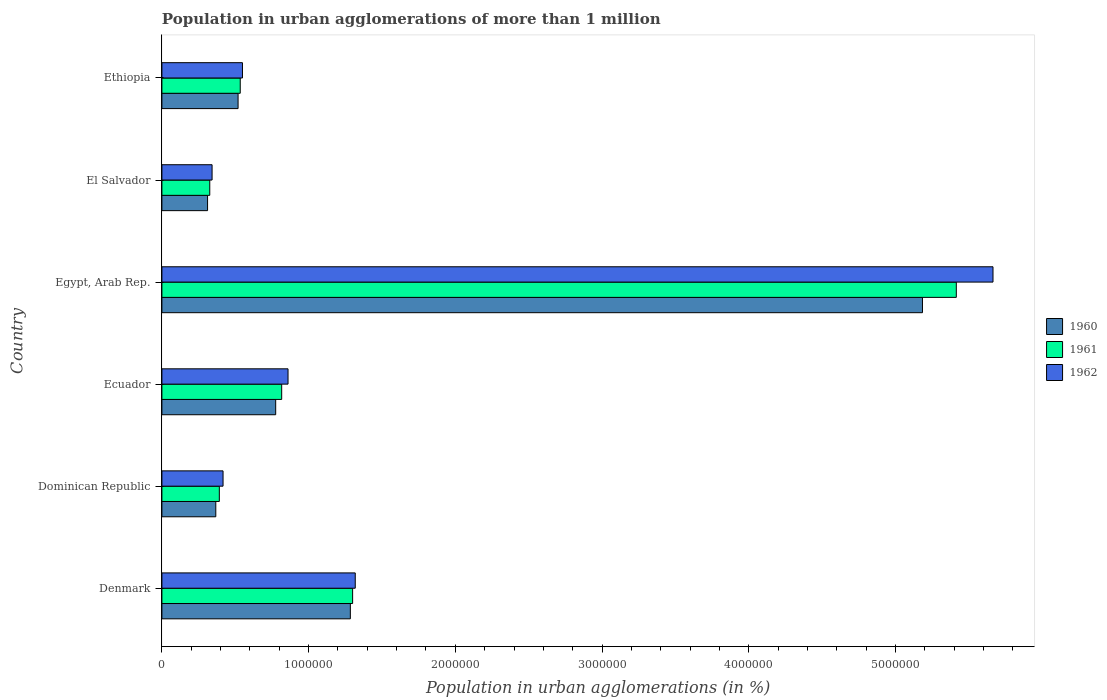How many different coloured bars are there?
Provide a short and direct response. 3. How many groups of bars are there?
Ensure brevity in your answer.  6. Are the number of bars per tick equal to the number of legend labels?
Offer a very short reply. Yes. Are the number of bars on each tick of the Y-axis equal?
Your answer should be compact. Yes. How many bars are there on the 4th tick from the bottom?
Provide a short and direct response. 3. What is the label of the 5th group of bars from the top?
Offer a terse response. Dominican Republic. In how many cases, is the number of bars for a given country not equal to the number of legend labels?
Your answer should be compact. 0. What is the population in urban agglomerations in 1960 in Denmark?
Make the answer very short. 1.28e+06. Across all countries, what is the maximum population in urban agglomerations in 1962?
Your response must be concise. 5.66e+06. Across all countries, what is the minimum population in urban agglomerations in 1962?
Keep it short and to the point. 3.42e+05. In which country was the population in urban agglomerations in 1962 maximum?
Ensure brevity in your answer.  Egypt, Arab Rep. In which country was the population in urban agglomerations in 1962 minimum?
Ensure brevity in your answer.  El Salvador. What is the total population in urban agglomerations in 1962 in the graph?
Provide a short and direct response. 9.15e+06. What is the difference between the population in urban agglomerations in 1962 in Egypt, Arab Rep. and that in Ethiopia?
Your answer should be compact. 5.12e+06. What is the difference between the population in urban agglomerations in 1962 in El Salvador and the population in urban agglomerations in 1961 in Ethiopia?
Provide a short and direct response. -1.92e+05. What is the average population in urban agglomerations in 1960 per country?
Ensure brevity in your answer.  1.41e+06. What is the difference between the population in urban agglomerations in 1961 and population in urban agglomerations in 1962 in Ethiopia?
Make the answer very short. -1.52e+04. In how many countries, is the population in urban agglomerations in 1960 greater than 1000000 %?
Provide a short and direct response. 2. What is the ratio of the population in urban agglomerations in 1962 in Ecuador to that in Egypt, Arab Rep.?
Provide a succinct answer. 0.15. What is the difference between the highest and the second highest population in urban agglomerations in 1962?
Ensure brevity in your answer.  4.35e+06. What is the difference between the highest and the lowest population in urban agglomerations in 1960?
Provide a short and direct response. 4.87e+06. In how many countries, is the population in urban agglomerations in 1960 greater than the average population in urban agglomerations in 1960 taken over all countries?
Provide a succinct answer. 1. Is the sum of the population in urban agglomerations in 1960 in Egypt, Arab Rep. and El Salvador greater than the maximum population in urban agglomerations in 1961 across all countries?
Ensure brevity in your answer.  Yes. What does the 2nd bar from the top in Dominican Republic represents?
Ensure brevity in your answer.  1961. How many countries are there in the graph?
Your answer should be very brief. 6. What is the difference between two consecutive major ticks on the X-axis?
Your answer should be compact. 1.00e+06. Are the values on the major ticks of X-axis written in scientific E-notation?
Provide a short and direct response. No. Does the graph contain any zero values?
Your answer should be very brief. No. Does the graph contain grids?
Offer a terse response. No. Where does the legend appear in the graph?
Keep it short and to the point. Center right. How are the legend labels stacked?
Offer a terse response. Vertical. What is the title of the graph?
Offer a very short reply. Population in urban agglomerations of more than 1 million. What is the label or title of the X-axis?
Provide a short and direct response. Population in urban agglomerations (in %). What is the label or title of the Y-axis?
Your response must be concise. Country. What is the Population in urban agglomerations (in %) in 1960 in Denmark?
Offer a terse response. 1.28e+06. What is the Population in urban agglomerations (in %) in 1961 in Denmark?
Keep it short and to the point. 1.30e+06. What is the Population in urban agglomerations (in %) in 1962 in Denmark?
Your answer should be very brief. 1.32e+06. What is the Population in urban agglomerations (in %) of 1960 in Dominican Republic?
Give a very brief answer. 3.67e+05. What is the Population in urban agglomerations (in %) of 1961 in Dominican Republic?
Keep it short and to the point. 3.91e+05. What is the Population in urban agglomerations (in %) of 1962 in Dominican Republic?
Offer a very short reply. 4.17e+05. What is the Population in urban agglomerations (in %) of 1960 in Ecuador?
Provide a succinct answer. 7.76e+05. What is the Population in urban agglomerations (in %) in 1961 in Ecuador?
Your answer should be compact. 8.16e+05. What is the Population in urban agglomerations (in %) in 1962 in Ecuador?
Give a very brief answer. 8.60e+05. What is the Population in urban agglomerations (in %) in 1960 in Egypt, Arab Rep.?
Give a very brief answer. 5.18e+06. What is the Population in urban agglomerations (in %) of 1961 in Egypt, Arab Rep.?
Your response must be concise. 5.41e+06. What is the Population in urban agglomerations (in %) in 1962 in Egypt, Arab Rep.?
Give a very brief answer. 5.66e+06. What is the Population in urban agglomerations (in %) in 1960 in El Salvador?
Your answer should be very brief. 3.11e+05. What is the Population in urban agglomerations (in %) of 1961 in El Salvador?
Your answer should be very brief. 3.26e+05. What is the Population in urban agglomerations (in %) of 1962 in El Salvador?
Make the answer very short. 3.42e+05. What is the Population in urban agglomerations (in %) in 1960 in Ethiopia?
Your answer should be very brief. 5.19e+05. What is the Population in urban agglomerations (in %) of 1961 in Ethiopia?
Give a very brief answer. 5.34e+05. What is the Population in urban agglomerations (in %) of 1962 in Ethiopia?
Your answer should be compact. 5.49e+05. Across all countries, what is the maximum Population in urban agglomerations (in %) in 1960?
Give a very brief answer. 5.18e+06. Across all countries, what is the maximum Population in urban agglomerations (in %) in 1961?
Give a very brief answer. 5.41e+06. Across all countries, what is the maximum Population in urban agglomerations (in %) in 1962?
Provide a short and direct response. 5.66e+06. Across all countries, what is the minimum Population in urban agglomerations (in %) of 1960?
Make the answer very short. 3.11e+05. Across all countries, what is the minimum Population in urban agglomerations (in %) of 1961?
Give a very brief answer. 3.26e+05. Across all countries, what is the minimum Population in urban agglomerations (in %) in 1962?
Offer a terse response. 3.42e+05. What is the total Population in urban agglomerations (in %) of 1960 in the graph?
Your answer should be very brief. 8.44e+06. What is the total Population in urban agglomerations (in %) in 1961 in the graph?
Give a very brief answer. 8.78e+06. What is the total Population in urban agglomerations (in %) of 1962 in the graph?
Make the answer very short. 9.15e+06. What is the difference between the Population in urban agglomerations (in %) of 1960 in Denmark and that in Dominican Republic?
Offer a terse response. 9.17e+05. What is the difference between the Population in urban agglomerations (in %) of 1961 in Denmark and that in Dominican Republic?
Your answer should be compact. 9.09e+05. What is the difference between the Population in urban agglomerations (in %) in 1962 in Denmark and that in Dominican Republic?
Provide a succinct answer. 9.01e+05. What is the difference between the Population in urban agglomerations (in %) in 1960 in Denmark and that in Ecuador?
Keep it short and to the point. 5.09e+05. What is the difference between the Population in urban agglomerations (in %) of 1961 in Denmark and that in Ecuador?
Your answer should be very brief. 4.83e+05. What is the difference between the Population in urban agglomerations (in %) of 1962 in Denmark and that in Ecuador?
Your response must be concise. 4.58e+05. What is the difference between the Population in urban agglomerations (in %) of 1960 in Denmark and that in Egypt, Arab Rep.?
Provide a succinct answer. -3.90e+06. What is the difference between the Population in urban agglomerations (in %) of 1961 in Denmark and that in Egypt, Arab Rep.?
Your response must be concise. -4.11e+06. What is the difference between the Population in urban agglomerations (in %) of 1962 in Denmark and that in Egypt, Arab Rep.?
Make the answer very short. -4.35e+06. What is the difference between the Population in urban agglomerations (in %) in 1960 in Denmark and that in El Salvador?
Offer a very short reply. 9.73e+05. What is the difference between the Population in urban agglomerations (in %) of 1961 in Denmark and that in El Salvador?
Provide a short and direct response. 9.74e+05. What is the difference between the Population in urban agglomerations (in %) in 1962 in Denmark and that in El Salvador?
Offer a very short reply. 9.76e+05. What is the difference between the Population in urban agglomerations (in %) in 1960 in Denmark and that in Ethiopia?
Make the answer very short. 7.65e+05. What is the difference between the Population in urban agglomerations (in %) in 1961 in Denmark and that in Ethiopia?
Offer a very short reply. 7.66e+05. What is the difference between the Population in urban agglomerations (in %) of 1962 in Denmark and that in Ethiopia?
Provide a short and direct response. 7.69e+05. What is the difference between the Population in urban agglomerations (in %) of 1960 in Dominican Republic and that in Ecuador?
Provide a short and direct response. -4.08e+05. What is the difference between the Population in urban agglomerations (in %) in 1961 in Dominican Republic and that in Ecuador?
Provide a succinct answer. -4.25e+05. What is the difference between the Population in urban agglomerations (in %) in 1962 in Dominican Republic and that in Ecuador?
Provide a short and direct response. -4.43e+05. What is the difference between the Population in urban agglomerations (in %) in 1960 in Dominican Republic and that in Egypt, Arab Rep.?
Give a very brief answer. -4.82e+06. What is the difference between the Population in urban agglomerations (in %) in 1961 in Dominican Republic and that in Egypt, Arab Rep.?
Provide a succinct answer. -5.02e+06. What is the difference between the Population in urban agglomerations (in %) in 1962 in Dominican Republic and that in Egypt, Arab Rep.?
Offer a terse response. -5.25e+06. What is the difference between the Population in urban agglomerations (in %) of 1960 in Dominican Republic and that in El Salvador?
Keep it short and to the point. 5.61e+04. What is the difference between the Population in urban agglomerations (in %) in 1961 in Dominican Republic and that in El Salvador?
Your response must be concise. 6.52e+04. What is the difference between the Population in urban agglomerations (in %) in 1962 in Dominican Republic and that in El Salvador?
Ensure brevity in your answer.  7.48e+04. What is the difference between the Population in urban agglomerations (in %) in 1960 in Dominican Republic and that in Ethiopia?
Keep it short and to the point. -1.52e+05. What is the difference between the Population in urban agglomerations (in %) in 1961 in Dominican Republic and that in Ethiopia?
Your response must be concise. -1.43e+05. What is the difference between the Population in urban agglomerations (in %) of 1962 in Dominican Republic and that in Ethiopia?
Offer a terse response. -1.32e+05. What is the difference between the Population in urban agglomerations (in %) of 1960 in Ecuador and that in Egypt, Arab Rep.?
Your answer should be very brief. -4.41e+06. What is the difference between the Population in urban agglomerations (in %) in 1961 in Ecuador and that in Egypt, Arab Rep.?
Provide a short and direct response. -4.60e+06. What is the difference between the Population in urban agglomerations (in %) of 1962 in Ecuador and that in Egypt, Arab Rep.?
Offer a terse response. -4.81e+06. What is the difference between the Population in urban agglomerations (in %) of 1960 in Ecuador and that in El Salvador?
Make the answer very short. 4.64e+05. What is the difference between the Population in urban agglomerations (in %) of 1961 in Ecuador and that in El Salvador?
Provide a short and direct response. 4.90e+05. What is the difference between the Population in urban agglomerations (in %) of 1962 in Ecuador and that in El Salvador?
Provide a succinct answer. 5.18e+05. What is the difference between the Population in urban agglomerations (in %) of 1960 in Ecuador and that in Ethiopia?
Your answer should be very brief. 2.56e+05. What is the difference between the Population in urban agglomerations (in %) of 1961 in Ecuador and that in Ethiopia?
Give a very brief answer. 2.83e+05. What is the difference between the Population in urban agglomerations (in %) in 1962 in Ecuador and that in Ethiopia?
Your answer should be compact. 3.11e+05. What is the difference between the Population in urban agglomerations (in %) of 1960 in Egypt, Arab Rep. and that in El Salvador?
Provide a short and direct response. 4.87e+06. What is the difference between the Population in urban agglomerations (in %) in 1961 in Egypt, Arab Rep. and that in El Salvador?
Keep it short and to the point. 5.09e+06. What is the difference between the Population in urban agglomerations (in %) in 1962 in Egypt, Arab Rep. and that in El Salvador?
Provide a short and direct response. 5.32e+06. What is the difference between the Population in urban agglomerations (in %) of 1960 in Egypt, Arab Rep. and that in Ethiopia?
Provide a succinct answer. 4.66e+06. What is the difference between the Population in urban agglomerations (in %) of 1961 in Egypt, Arab Rep. and that in Ethiopia?
Offer a terse response. 4.88e+06. What is the difference between the Population in urban agglomerations (in %) of 1962 in Egypt, Arab Rep. and that in Ethiopia?
Your answer should be very brief. 5.12e+06. What is the difference between the Population in urban agglomerations (in %) in 1960 in El Salvador and that in Ethiopia?
Your answer should be very brief. -2.08e+05. What is the difference between the Population in urban agglomerations (in %) of 1961 in El Salvador and that in Ethiopia?
Your answer should be very brief. -2.08e+05. What is the difference between the Population in urban agglomerations (in %) in 1962 in El Salvador and that in Ethiopia?
Ensure brevity in your answer.  -2.07e+05. What is the difference between the Population in urban agglomerations (in %) of 1960 in Denmark and the Population in urban agglomerations (in %) of 1961 in Dominican Republic?
Your response must be concise. 8.93e+05. What is the difference between the Population in urban agglomerations (in %) of 1960 in Denmark and the Population in urban agglomerations (in %) of 1962 in Dominican Republic?
Offer a terse response. 8.68e+05. What is the difference between the Population in urban agglomerations (in %) in 1961 in Denmark and the Population in urban agglomerations (in %) in 1962 in Dominican Republic?
Your response must be concise. 8.83e+05. What is the difference between the Population in urban agglomerations (in %) of 1960 in Denmark and the Population in urban agglomerations (in %) of 1961 in Ecuador?
Provide a short and direct response. 4.68e+05. What is the difference between the Population in urban agglomerations (in %) of 1960 in Denmark and the Population in urban agglomerations (in %) of 1962 in Ecuador?
Your response must be concise. 4.25e+05. What is the difference between the Population in urban agglomerations (in %) of 1961 in Denmark and the Population in urban agglomerations (in %) of 1962 in Ecuador?
Your response must be concise. 4.40e+05. What is the difference between the Population in urban agglomerations (in %) in 1960 in Denmark and the Population in urban agglomerations (in %) in 1961 in Egypt, Arab Rep.?
Provide a short and direct response. -4.13e+06. What is the difference between the Population in urban agglomerations (in %) of 1960 in Denmark and the Population in urban agglomerations (in %) of 1962 in Egypt, Arab Rep.?
Your answer should be compact. -4.38e+06. What is the difference between the Population in urban agglomerations (in %) in 1961 in Denmark and the Population in urban agglomerations (in %) in 1962 in Egypt, Arab Rep.?
Ensure brevity in your answer.  -4.36e+06. What is the difference between the Population in urban agglomerations (in %) in 1960 in Denmark and the Population in urban agglomerations (in %) in 1961 in El Salvador?
Provide a short and direct response. 9.58e+05. What is the difference between the Population in urban agglomerations (in %) of 1960 in Denmark and the Population in urban agglomerations (in %) of 1962 in El Salvador?
Your answer should be compact. 9.42e+05. What is the difference between the Population in urban agglomerations (in %) of 1961 in Denmark and the Population in urban agglomerations (in %) of 1962 in El Salvador?
Offer a terse response. 9.58e+05. What is the difference between the Population in urban agglomerations (in %) of 1960 in Denmark and the Population in urban agglomerations (in %) of 1961 in Ethiopia?
Offer a very short reply. 7.50e+05. What is the difference between the Population in urban agglomerations (in %) in 1960 in Denmark and the Population in urban agglomerations (in %) in 1962 in Ethiopia?
Offer a terse response. 7.35e+05. What is the difference between the Population in urban agglomerations (in %) of 1961 in Denmark and the Population in urban agglomerations (in %) of 1962 in Ethiopia?
Your answer should be very brief. 7.51e+05. What is the difference between the Population in urban agglomerations (in %) in 1960 in Dominican Republic and the Population in urban agglomerations (in %) in 1961 in Ecuador?
Your answer should be compact. -4.49e+05. What is the difference between the Population in urban agglomerations (in %) in 1960 in Dominican Republic and the Population in urban agglomerations (in %) in 1962 in Ecuador?
Provide a succinct answer. -4.92e+05. What is the difference between the Population in urban agglomerations (in %) of 1961 in Dominican Republic and the Population in urban agglomerations (in %) of 1962 in Ecuador?
Provide a short and direct response. -4.68e+05. What is the difference between the Population in urban agglomerations (in %) of 1960 in Dominican Republic and the Population in urban agglomerations (in %) of 1961 in Egypt, Arab Rep.?
Make the answer very short. -5.05e+06. What is the difference between the Population in urban agglomerations (in %) of 1960 in Dominican Republic and the Population in urban agglomerations (in %) of 1962 in Egypt, Arab Rep.?
Ensure brevity in your answer.  -5.30e+06. What is the difference between the Population in urban agglomerations (in %) of 1961 in Dominican Republic and the Population in urban agglomerations (in %) of 1962 in Egypt, Arab Rep.?
Provide a short and direct response. -5.27e+06. What is the difference between the Population in urban agglomerations (in %) in 1960 in Dominican Republic and the Population in urban agglomerations (in %) in 1961 in El Salvador?
Your answer should be very brief. 4.11e+04. What is the difference between the Population in urban agglomerations (in %) in 1960 in Dominican Republic and the Population in urban agglomerations (in %) in 1962 in El Salvador?
Your response must be concise. 2.53e+04. What is the difference between the Population in urban agglomerations (in %) of 1961 in Dominican Republic and the Population in urban agglomerations (in %) of 1962 in El Salvador?
Offer a very short reply. 4.94e+04. What is the difference between the Population in urban agglomerations (in %) in 1960 in Dominican Republic and the Population in urban agglomerations (in %) in 1961 in Ethiopia?
Offer a very short reply. -1.67e+05. What is the difference between the Population in urban agglomerations (in %) in 1960 in Dominican Republic and the Population in urban agglomerations (in %) in 1962 in Ethiopia?
Keep it short and to the point. -1.82e+05. What is the difference between the Population in urban agglomerations (in %) in 1961 in Dominican Republic and the Population in urban agglomerations (in %) in 1962 in Ethiopia?
Ensure brevity in your answer.  -1.58e+05. What is the difference between the Population in urban agglomerations (in %) of 1960 in Ecuador and the Population in urban agglomerations (in %) of 1961 in Egypt, Arab Rep.?
Provide a short and direct response. -4.64e+06. What is the difference between the Population in urban agglomerations (in %) in 1960 in Ecuador and the Population in urban agglomerations (in %) in 1962 in Egypt, Arab Rep.?
Your response must be concise. -4.89e+06. What is the difference between the Population in urban agglomerations (in %) in 1961 in Ecuador and the Population in urban agglomerations (in %) in 1962 in Egypt, Arab Rep.?
Keep it short and to the point. -4.85e+06. What is the difference between the Population in urban agglomerations (in %) of 1960 in Ecuador and the Population in urban agglomerations (in %) of 1961 in El Salvador?
Keep it short and to the point. 4.49e+05. What is the difference between the Population in urban agglomerations (in %) in 1960 in Ecuador and the Population in urban agglomerations (in %) in 1962 in El Salvador?
Make the answer very short. 4.34e+05. What is the difference between the Population in urban agglomerations (in %) of 1961 in Ecuador and the Population in urban agglomerations (in %) of 1962 in El Salvador?
Provide a short and direct response. 4.74e+05. What is the difference between the Population in urban agglomerations (in %) of 1960 in Ecuador and the Population in urban agglomerations (in %) of 1961 in Ethiopia?
Provide a succinct answer. 2.42e+05. What is the difference between the Population in urban agglomerations (in %) of 1960 in Ecuador and the Population in urban agglomerations (in %) of 1962 in Ethiopia?
Provide a succinct answer. 2.26e+05. What is the difference between the Population in urban agglomerations (in %) in 1961 in Ecuador and the Population in urban agglomerations (in %) in 1962 in Ethiopia?
Your answer should be very brief. 2.67e+05. What is the difference between the Population in urban agglomerations (in %) of 1960 in Egypt, Arab Rep. and the Population in urban agglomerations (in %) of 1961 in El Salvador?
Offer a very short reply. 4.86e+06. What is the difference between the Population in urban agglomerations (in %) in 1960 in Egypt, Arab Rep. and the Population in urban agglomerations (in %) in 1962 in El Salvador?
Ensure brevity in your answer.  4.84e+06. What is the difference between the Population in urban agglomerations (in %) in 1961 in Egypt, Arab Rep. and the Population in urban agglomerations (in %) in 1962 in El Salvador?
Make the answer very short. 5.07e+06. What is the difference between the Population in urban agglomerations (in %) in 1960 in Egypt, Arab Rep. and the Population in urban agglomerations (in %) in 1961 in Ethiopia?
Give a very brief answer. 4.65e+06. What is the difference between the Population in urban agglomerations (in %) in 1960 in Egypt, Arab Rep. and the Population in urban agglomerations (in %) in 1962 in Ethiopia?
Ensure brevity in your answer.  4.63e+06. What is the difference between the Population in urban agglomerations (in %) of 1961 in Egypt, Arab Rep. and the Population in urban agglomerations (in %) of 1962 in Ethiopia?
Offer a very short reply. 4.87e+06. What is the difference between the Population in urban agglomerations (in %) of 1960 in El Salvador and the Population in urban agglomerations (in %) of 1961 in Ethiopia?
Keep it short and to the point. -2.23e+05. What is the difference between the Population in urban agglomerations (in %) in 1960 in El Salvador and the Population in urban agglomerations (in %) in 1962 in Ethiopia?
Your answer should be compact. -2.38e+05. What is the difference between the Population in urban agglomerations (in %) of 1961 in El Salvador and the Population in urban agglomerations (in %) of 1962 in Ethiopia?
Your answer should be very brief. -2.23e+05. What is the average Population in urban agglomerations (in %) in 1960 per country?
Offer a terse response. 1.41e+06. What is the average Population in urban agglomerations (in %) of 1961 per country?
Make the answer very short. 1.46e+06. What is the average Population in urban agglomerations (in %) in 1962 per country?
Your answer should be very brief. 1.53e+06. What is the difference between the Population in urban agglomerations (in %) in 1960 and Population in urban agglomerations (in %) in 1961 in Denmark?
Provide a succinct answer. -1.55e+04. What is the difference between the Population in urban agglomerations (in %) in 1960 and Population in urban agglomerations (in %) in 1962 in Denmark?
Your answer should be compact. -3.34e+04. What is the difference between the Population in urban agglomerations (in %) of 1961 and Population in urban agglomerations (in %) of 1962 in Denmark?
Keep it short and to the point. -1.79e+04. What is the difference between the Population in urban agglomerations (in %) in 1960 and Population in urban agglomerations (in %) in 1961 in Dominican Republic?
Your answer should be compact. -2.41e+04. What is the difference between the Population in urban agglomerations (in %) in 1960 and Population in urban agglomerations (in %) in 1962 in Dominican Republic?
Offer a terse response. -4.95e+04. What is the difference between the Population in urban agglomerations (in %) in 1961 and Population in urban agglomerations (in %) in 1962 in Dominican Republic?
Your answer should be very brief. -2.54e+04. What is the difference between the Population in urban agglomerations (in %) in 1960 and Population in urban agglomerations (in %) in 1961 in Ecuador?
Provide a succinct answer. -4.09e+04. What is the difference between the Population in urban agglomerations (in %) in 1960 and Population in urban agglomerations (in %) in 1962 in Ecuador?
Provide a succinct answer. -8.41e+04. What is the difference between the Population in urban agglomerations (in %) in 1961 and Population in urban agglomerations (in %) in 1962 in Ecuador?
Ensure brevity in your answer.  -4.32e+04. What is the difference between the Population in urban agglomerations (in %) of 1960 and Population in urban agglomerations (in %) of 1961 in Egypt, Arab Rep.?
Keep it short and to the point. -2.31e+05. What is the difference between the Population in urban agglomerations (in %) of 1960 and Population in urban agglomerations (in %) of 1962 in Egypt, Arab Rep.?
Keep it short and to the point. -4.81e+05. What is the difference between the Population in urban agglomerations (in %) of 1961 and Population in urban agglomerations (in %) of 1962 in Egypt, Arab Rep.?
Offer a terse response. -2.50e+05. What is the difference between the Population in urban agglomerations (in %) of 1960 and Population in urban agglomerations (in %) of 1961 in El Salvador?
Make the answer very short. -1.50e+04. What is the difference between the Population in urban agglomerations (in %) of 1960 and Population in urban agglomerations (in %) of 1962 in El Salvador?
Provide a short and direct response. -3.08e+04. What is the difference between the Population in urban agglomerations (in %) in 1961 and Population in urban agglomerations (in %) in 1962 in El Salvador?
Offer a very short reply. -1.58e+04. What is the difference between the Population in urban agglomerations (in %) of 1960 and Population in urban agglomerations (in %) of 1961 in Ethiopia?
Offer a very short reply. -1.48e+04. What is the difference between the Population in urban agglomerations (in %) in 1960 and Population in urban agglomerations (in %) in 1962 in Ethiopia?
Keep it short and to the point. -3.00e+04. What is the difference between the Population in urban agglomerations (in %) in 1961 and Population in urban agglomerations (in %) in 1962 in Ethiopia?
Your answer should be compact. -1.52e+04. What is the ratio of the Population in urban agglomerations (in %) of 1960 in Denmark to that in Dominican Republic?
Your answer should be very brief. 3.5. What is the ratio of the Population in urban agglomerations (in %) of 1961 in Denmark to that in Dominican Republic?
Keep it short and to the point. 3.32. What is the ratio of the Population in urban agglomerations (in %) in 1962 in Denmark to that in Dominican Republic?
Your response must be concise. 3.16. What is the ratio of the Population in urban agglomerations (in %) in 1960 in Denmark to that in Ecuador?
Keep it short and to the point. 1.66. What is the ratio of the Population in urban agglomerations (in %) in 1961 in Denmark to that in Ecuador?
Your answer should be very brief. 1.59. What is the ratio of the Population in urban agglomerations (in %) in 1962 in Denmark to that in Ecuador?
Provide a short and direct response. 1.53. What is the ratio of the Population in urban agglomerations (in %) in 1960 in Denmark to that in Egypt, Arab Rep.?
Provide a succinct answer. 0.25. What is the ratio of the Population in urban agglomerations (in %) of 1961 in Denmark to that in Egypt, Arab Rep.?
Keep it short and to the point. 0.24. What is the ratio of the Population in urban agglomerations (in %) of 1962 in Denmark to that in Egypt, Arab Rep.?
Your answer should be compact. 0.23. What is the ratio of the Population in urban agglomerations (in %) of 1960 in Denmark to that in El Salvador?
Provide a short and direct response. 4.13. What is the ratio of the Population in urban agglomerations (in %) in 1961 in Denmark to that in El Salvador?
Your answer should be very brief. 3.98. What is the ratio of the Population in urban agglomerations (in %) of 1962 in Denmark to that in El Salvador?
Provide a short and direct response. 3.85. What is the ratio of the Population in urban agglomerations (in %) of 1960 in Denmark to that in Ethiopia?
Offer a terse response. 2.47. What is the ratio of the Population in urban agglomerations (in %) in 1961 in Denmark to that in Ethiopia?
Give a very brief answer. 2.43. What is the ratio of the Population in urban agglomerations (in %) in 1962 in Denmark to that in Ethiopia?
Ensure brevity in your answer.  2.4. What is the ratio of the Population in urban agglomerations (in %) of 1960 in Dominican Republic to that in Ecuador?
Your answer should be very brief. 0.47. What is the ratio of the Population in urban agglomerations (in %) of 1961 in Dominican Republic to that in Ecuador?
Keep it short and to the point. 0.48. What is the ratio of the Population in urban agglomerations (in %) in 1962 in Dominican Republic to that in Ecuador?
Keep it short and to the point. 0.48. What is the ratio of the Population in urban agglomerations (in %) in 1960 in Dominican Republic to that in Egypt, Arab Rep.?
Your response must be concise. 0.07. What is the ratio of the Population in urban agglomerations (in %) in 1961 in Dominican Republic to that in Egypt, Arab Rep.?
Keep it short and to the point. 0.07. What is the ratio of the Population in urban agglomerations (in %) of 1962 in Dominican Republic to that in Egypt, Arab Rep.?
Offer a terse response. 0.07. What is the ratio of the Population in urban agglomerations (in %) of 1960 in Dominican Republic to that in El Salvador?
Provide a succinct answer. 1.18. What is the ratio of the Population in urban agglomerations (in %) of 1961 in Dominican Republic to that in El Salvador?
Offer a terse response. 1.2. What is the ratio of the Population in urban agglomerations (in %) in 1962 in Dominican Republic to that in El Salvador?
Your answer should be very brief. 1.22. What is the ratio of the Population in urban agglomerations (in %) of 1960 in Dominican Republic to that in Ethiopia?
Offer a terse response. 0.71. What is the ratio of the Population in urban agglomerations (in %) of 1961 in Dominican Republic to that in Ethiopia?
Offer a very short reply. 0.73. What is the ratio of the Population in urban agglomerations (in %) in 1962 in Dominican Republic to that in Ethiopia?
Your answer should be compact. 0.76. What is the ratio of the Population in urban agglomerations (in %) in 1960 in Ecuador to that in Egypt, Arab Rep.?
Give a very brief answer. 0.15. What is the ratio of the Population in urban agglomerations (in %) of 1961 in Ecuador to that in Egypt, Arab Rep.?
Provide a short and direct response. 0.15. What is the ratio of the Population in urban agglomerations (in %) of 1962 in Ecuador to that in Egypt, Arab Rep.?
Ensure brevity in your answer.  0.15. What is the ratio of the Population in urban agglomerations (in %) of 1960 in Ecuador to that in El Salvador?
Provide a succinct answer. 2.49. What is the ratio of the Population in urban agglomerations (in %) in 1961 in Ecuador to that in El Salvador?
Provide a short and direct response. 2.5. What is the ratio of the Population in urban agglomerations (in %) in 1962 in Ecuador to that in El Salvador?
Make the answer very short. 2.51. What is the ratio of the Population in urban agglomerations (in %) in 1960 in Ecuador to that in Ethiopia?
Offer a terse response. 1.49. What is the ratio of the Population in urban agglomerations (in %) in 1961 in Ecuador to that in Ethiopia?
Ensure brevity in your answer.  1.53. What is the ratio of the Population in urban agglomerations (in %) in 1962 in Ecuador to that in Ethiopia?
Provide a short and direct response. 1.57. What is the ratio of the Population in urban agglomerations (in %) in 1960 in Egypt, Arab Rep. to that in El Salvador?
Your answer should be very brief. 16.66. What is the ratio of the Population in urban agglomerations (in %) of 1961 in Egypt, Arab Rep. to that in El Salvador?
Offer a very short reply. 16.6. What is the ratio of the Population in urban agglomerations (in %) of 1962 in Egypt, Arab Rep. to that in El Salvador?
Provide a succinct answer. 16.56. What is the ratio of the Population in urban agglomerations (in %) of 1960 in Egypt, Arab Rep. to that in Ethiopia?
Offer a very short reply. 9.98. What is the ratio of the Population in urban agglomerations (in %) in 1961 in Egypt, Arab Rep. to that in Ethiopia?
Offer a terse response. 10.14. What is the ratio of the Population in urban agglomerations (in %) of 1962 in Egypt, Arab Rep. to that in Ethiopia?
Your answer should be compact. 10.32. What is the ratio of the Population in urban agglomerations (in %) in 1960 in El Salvador to that in Ethiopia?
Provide a succinct answer. 0.6. What is the ratio of the Population in urban agglomerations (in %) in 1961 in El Salvador to that in Ethiopia?
Your answer should be very brief. 0.61. What is the ratio of the Population in urban agglomerations (in %) of 1962 in El Salvador to that in Ethiopia?
Offer a very short reply. 0.62. What is the difference between the highest and the second highest Population in urban agglomerations (in %) in 1960?
Provide a short and direct response. 3.90e+06. What is the difference between the highest and the second highest Population in urban agglomerations (in %) in 1961?
Your response must be concise. 4.11e+06. What is the difference between the highest and the second highest Population in urban agglomerations (in %) of 1962?
Keep it short and to the point. 4.35e+06. What is the difference between the highest and the lowest Population in urban agglomerations (in %) of 1960?
Provide a short and direct response. 4.87e+06. What is the difference between the highest and the lowest Population in urban agglomerations (in %) of 1961?
Provide a short and direct response. 5.09e+06. What is the difference between the highest and the lowest Population in urban agglomerations (in %) in 1962?
Ensure brevity in your answer.  5.32e+06. 